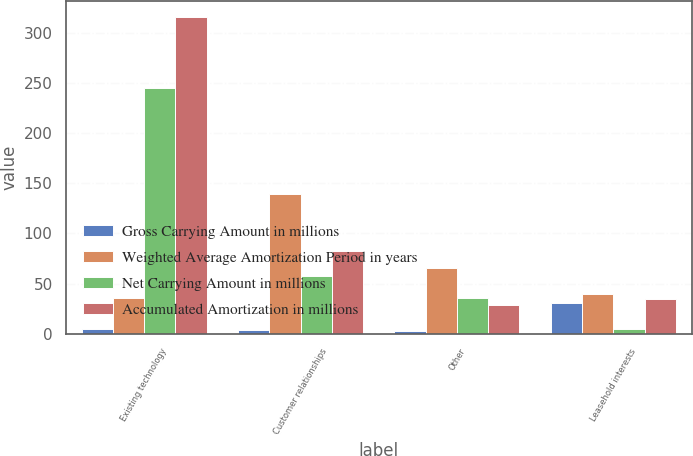Convert chart to OTSL. <chart><loc_0><loc_0><loc_500><loc_500><stacked_bar_chart><ecel><fcel>Existing technology<fcel>Customer relationships<fcel>Other<fcel>Leasehold interests<nl><fcel>Gross Carrying Amount in millions<fcel>5<fcel>4<fcel>3<fcel>31<nl><fcel>Weighted Average Amortization Period in years<fcel>36<fcel>139<fcel>65<fcel>40<nl><fcel>Net Carrying Amount in millions<fcel>245<fcel>57<fcel>36<fcel>5<nl><fcel>Accumulated Amortization in millions<fcel>316<fcel>82<fcel>29<fcel>35<nl></chart> 